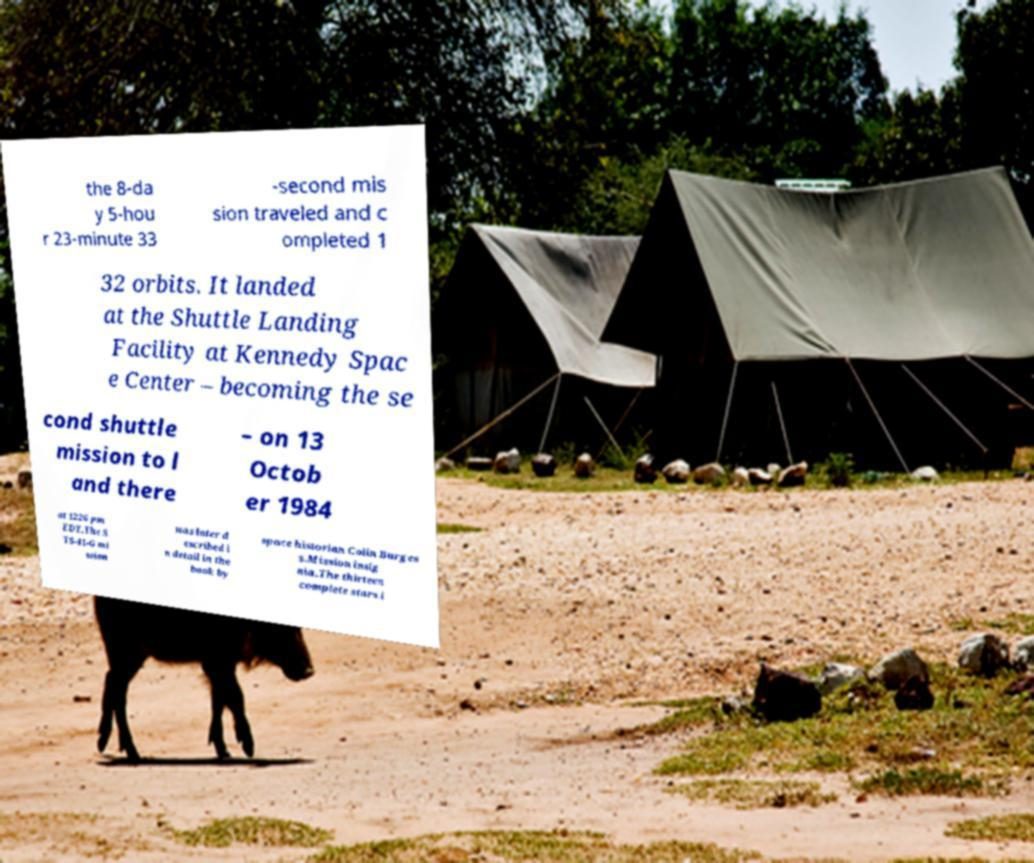Please identify and transcribe the text found in this image. the 8-da y 5-hou r 23-minute 33 -second mis sion traveled and c ompleted 1 32 orbits. It landed at the Shuttle Landing Facility at Kennedy Spac e Center – becoming the se cond shuttle mission to l and there – on 13 Octob er 1984 at 1226 pm EDT.The S TS-41-G mi ssion was later d escribed i n detail in the book by space historian Colin Burges s.Mission insig nia.The thirteen complete stars i 